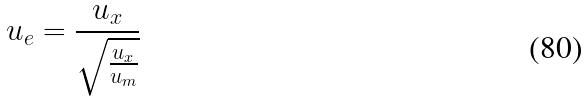<formula> <loc_0><loc_0><loc_500><loc_500>u _ { e } = \frac { u _ { x } } { \sqrt { \frac { u _ { x } } { u _ { m } } } }</formula> 